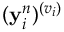Convert formula to latex. <formula><loc_0><loc_0><loc_500><loc_500>( y _ { i } ^ { n } ) ^ { ( v _ { i } ) }</formula> 